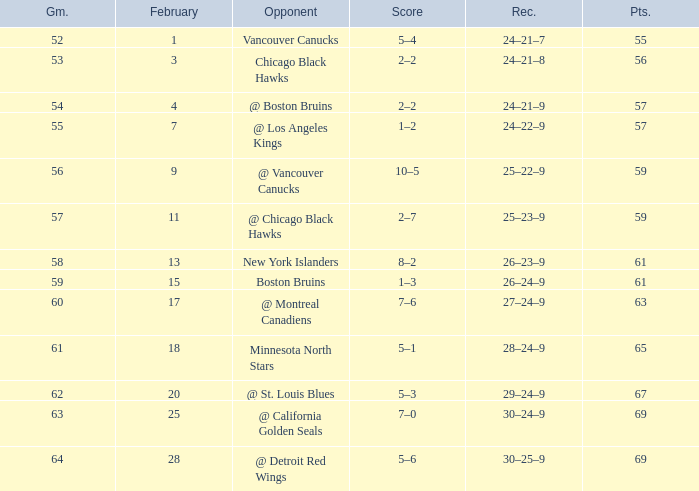How many games have a record of 30–25–9 and more points than 69? 0.0. 